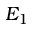<formula> <loc_0><loc_0><loc_500><loc_500>E _ { 1 }</formula> 